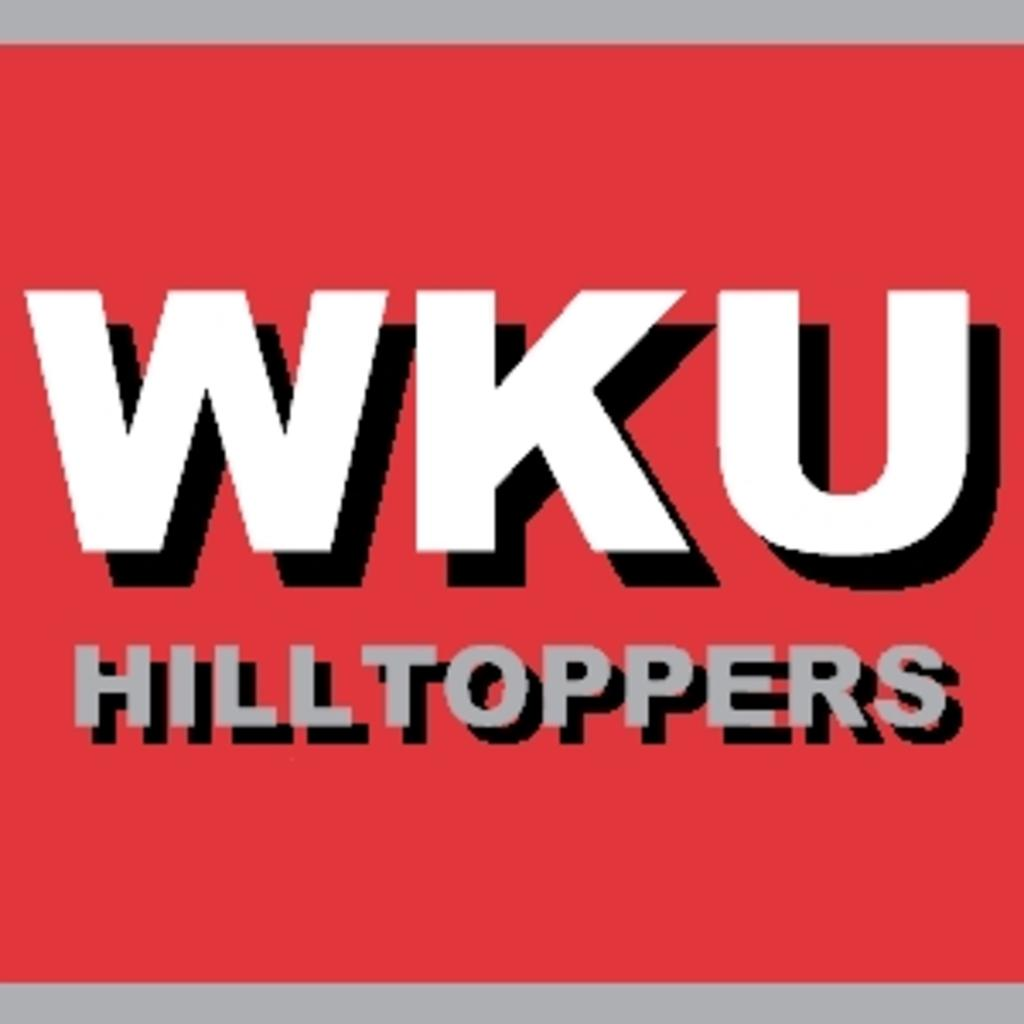What is present on the poster in the image? There is a poster in the image. What can be found on the poster besides the background? The poster has words on it. What color is the background of the poster? The background of the poster is red. Who is the creator of the society depicted on the poster? There is no society depicted on the poster, and therefore no creator can be identified. What type of blade is shown being used in the image? There is no blade present in the image. 